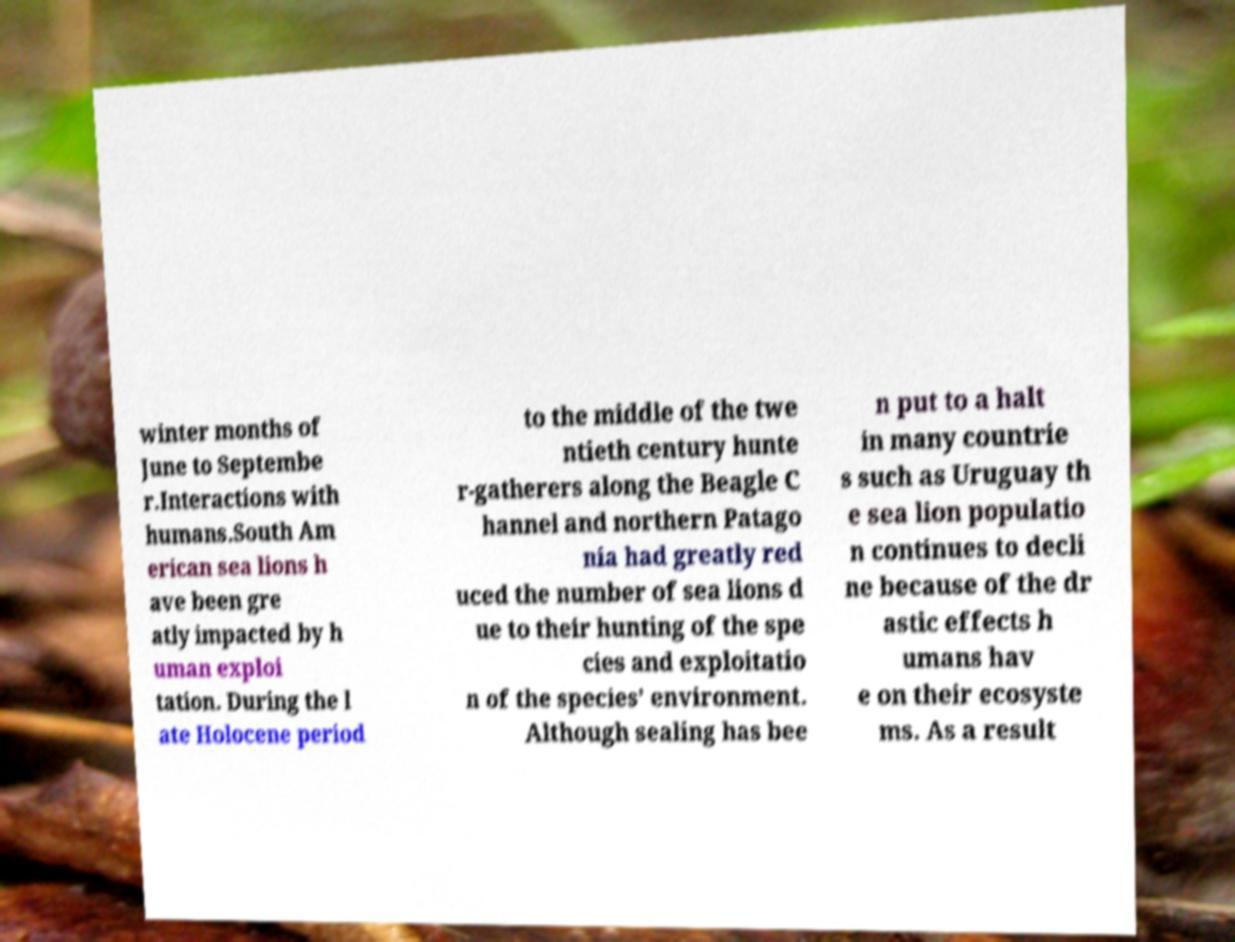For documentation purposes, I need the text within this image transcribed. Could you provide that? winter months of June to Septembe r.Interactions with humans.South Am erican sea lions h ave been gre atly impacted by h uman exploi tation. During the l ate Holocene period to the middle of the twe ntieth century hunte r-gatherers along the Beagle C hannel and northern Patago nia had greatly red uced the number of sea lions d ue to their hunting of the spe cies and exploitatio n of the species’ environment. Although sealing has bee n put to a halt in many countrie s such as Uruguay th e sea lion populatio n continues to decli ne because of the dr astic effects h umans hav e on their ecosyste ms. As a result 